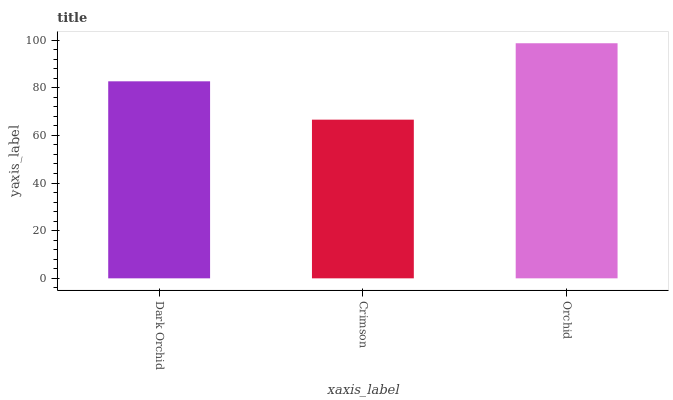Is Orchid the minimum?
Answer yes or no. No. Is Crimson the maximum?
Answer yes or no. No. Is Orchid greater than Crimson?
Answer yes or no. Yes. Is Crimson less than Orchid?
Answer yes or no. Yes. Is Crimson greater than Orchid?
Answer yes or no. No. Is Orchid less than Crimson?
Answer yes or no. No. Is Dark Orchid the high median?
Answer yes or no. Yes. Is Dark Orchid the low median?
Answer yes or no. Yes. Is Orchid the high median?
Answer yes or no. No. Is Orchid the low median?
Answer yes or no. No. 